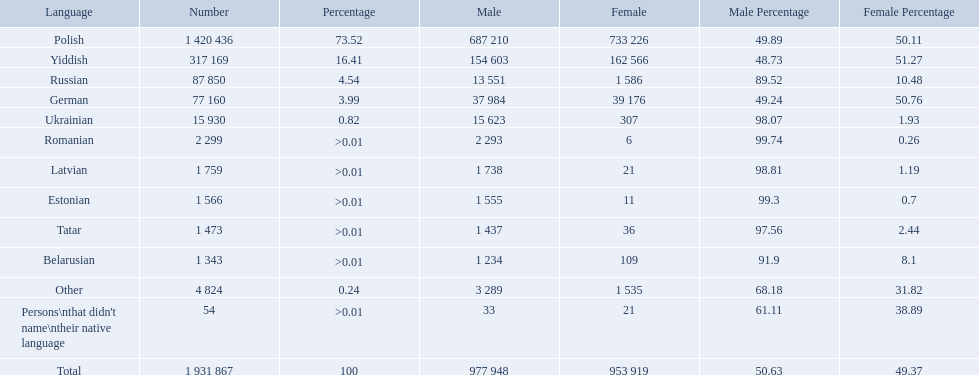What are all of the languages used in the warsaw governorate? Polish, Yiddish, Russian, German, Ukrainian, Romanian, Latvian, Estonian, Tatar, Belarusian, Other, Persons\nthat didn't name\ntheir native language. Which language was comprised of the least number of female speakers? Romanian. What languages are spoken in the warsaw governorate? Polish, Yiddish, Russian, German, Ukrainian, Romanian, Latvian, Estonian, Tatar, Belarusian. Which are the top five languages? Polish, Yiddish, Russian, German, Ukrainian. Of those which is the 2nd most frequently spoken? Yiddish. What were all the languages? Polish, Yiddish, Russian, German, Ukrainian, Romanian, Latvian, Estonian, Tatar, Belarusian, Other, Persons\nthat didn't name\ntheir native language. For these, how many people spoke them? 1 420 436, 317 169, 87 850, 77 160, 15 930, 2 299, 1 759, 1 566, 1 473, 1 343, 4 824, 54. Of these, which is the largest number of speakers? 1 420 436. Which language corresponds to this number? Polish. What are all the languages? Polish, Yiddish, Russian, German, Ukrainian, Romanian, Latvian, Estonian, Tatar, Belarusian, Other. Which only have percentages >0.01? Romanian, Latvian, Estonian, Tatar, Belarusian. Of these, which has the greatest number of speakers? Romanian. How many languages are shown? Polish, Yiddish, Russian, German, Ukrainian, Romanian, Latvian, Estonian, Tatar, Belarusian, Other. What language is in third place? Russian. What language is the most spoken after that one? German. 